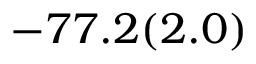Convert formula to latex. <formula><loc_0><loc_0><loc_500><loc_500>- 7 7 . 2 ( 2 . 0 )</formula> 